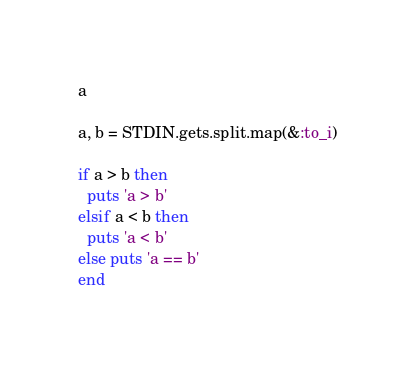Convert code to text. <code><loc_0><loc_0><loc_500><loc_500><_Ruby_>a

a, b = STDIN.gets.split.map(&:to_i)

if a > b then
  puts 'a > b'
elsif a < b then
  puts 'a < b'
else puts 'a == b'
end</code> 